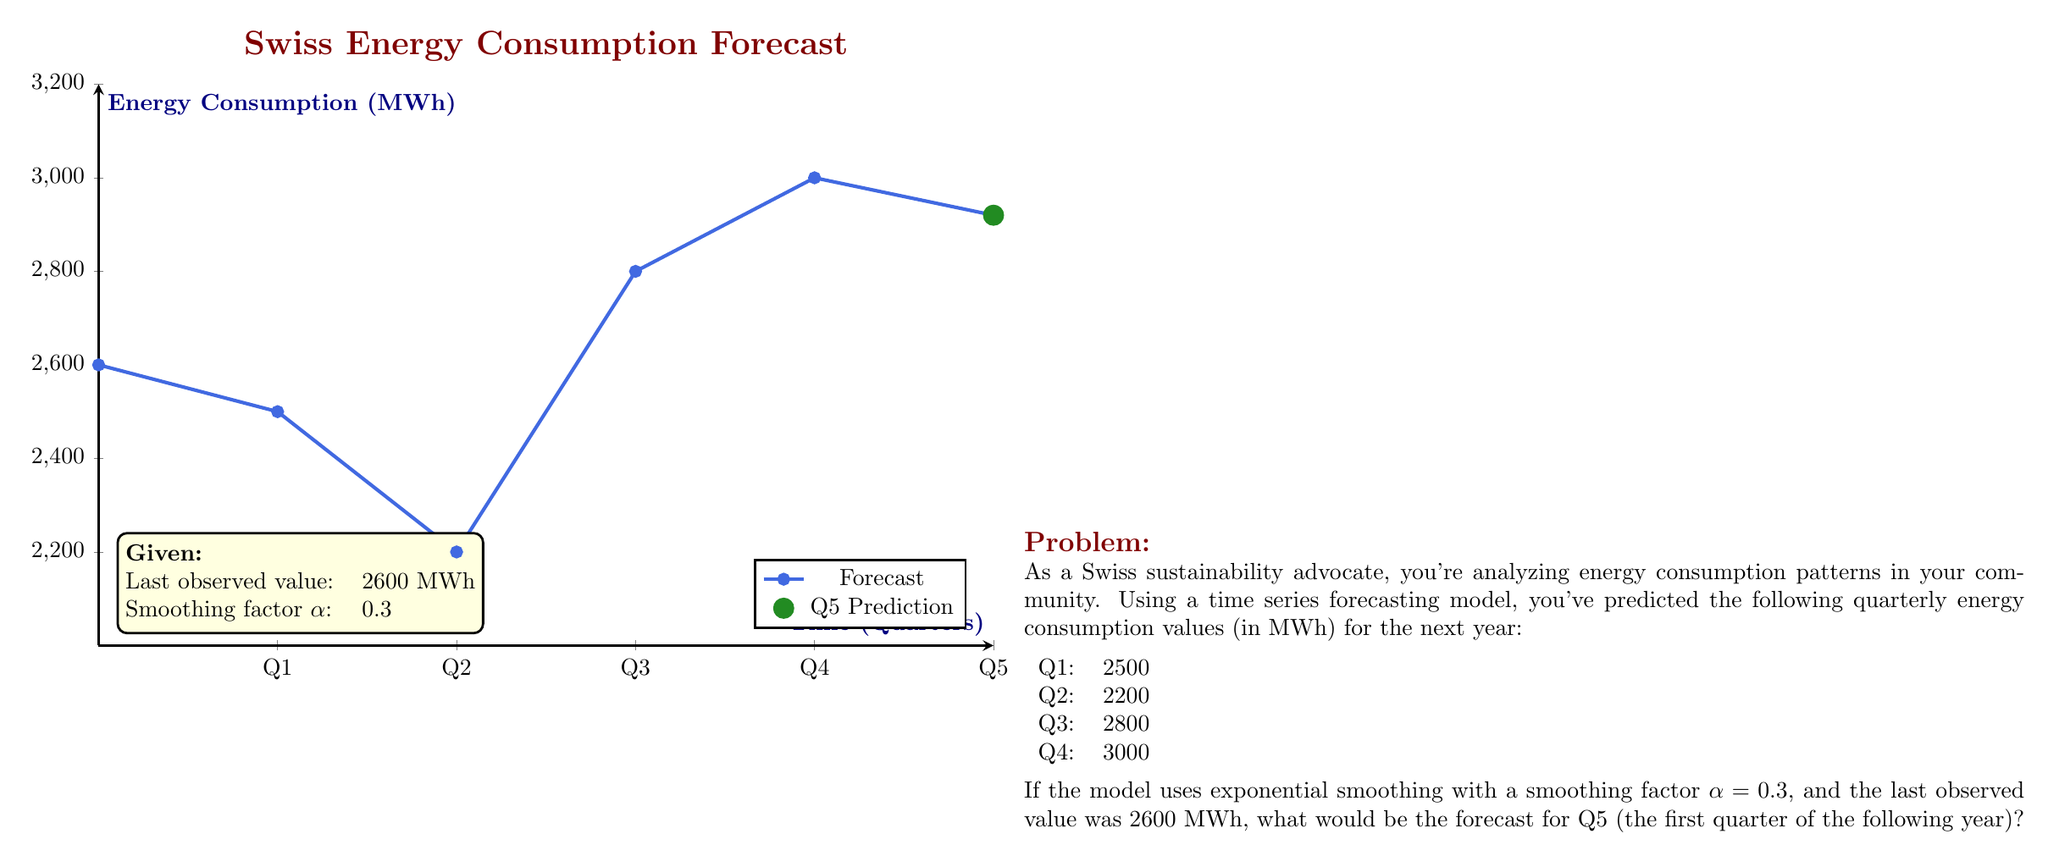What is the answer to this math problem? To solve this problem, we'll use the exponential smoothing formula:

$$F_{t+1} = \alpha Y_t + (1-\alpha)F_t$$

Where:
$F_{t+1}$ is the forecast for the next period
$\alpha$ is the smoothing factor (0.3 in this case)
$Y_t$ is the actual value in the current period
$F_t$ is the forecast for the current period

Step 1: Calculate the forecast for Q1
$F_{Q1} = 0.3 \times 2600 + (1-0.3) \times 2600 = 2600$

Step 2: Calculate the forecast for Q2
$F_{Q2} = 0.3 \times 2500 + (1-0.3) \times 2600 = 2570$

Step 3: Calculate the forecast for Q3
$F_{Q3} = 0.3 \times 2200 + (1-0.3) \times 2570 = 2459$

Step 4: Calculate the forecast for Q4
$F_{Q4} = 0.3 \times 2800 + (1-0.3) \times 2459 = 2561.3$

Step 5: Calculate the forecast for Q5
$F_{Q5} = 0.3 \times 3000 + (1-0.3) \times 2561.3 = 2692.91$

Therefore, the forecast for Q5 (the first quarter of the following year) is approximately 2692.91 MWh.
Answer: 2692.91 MWh 